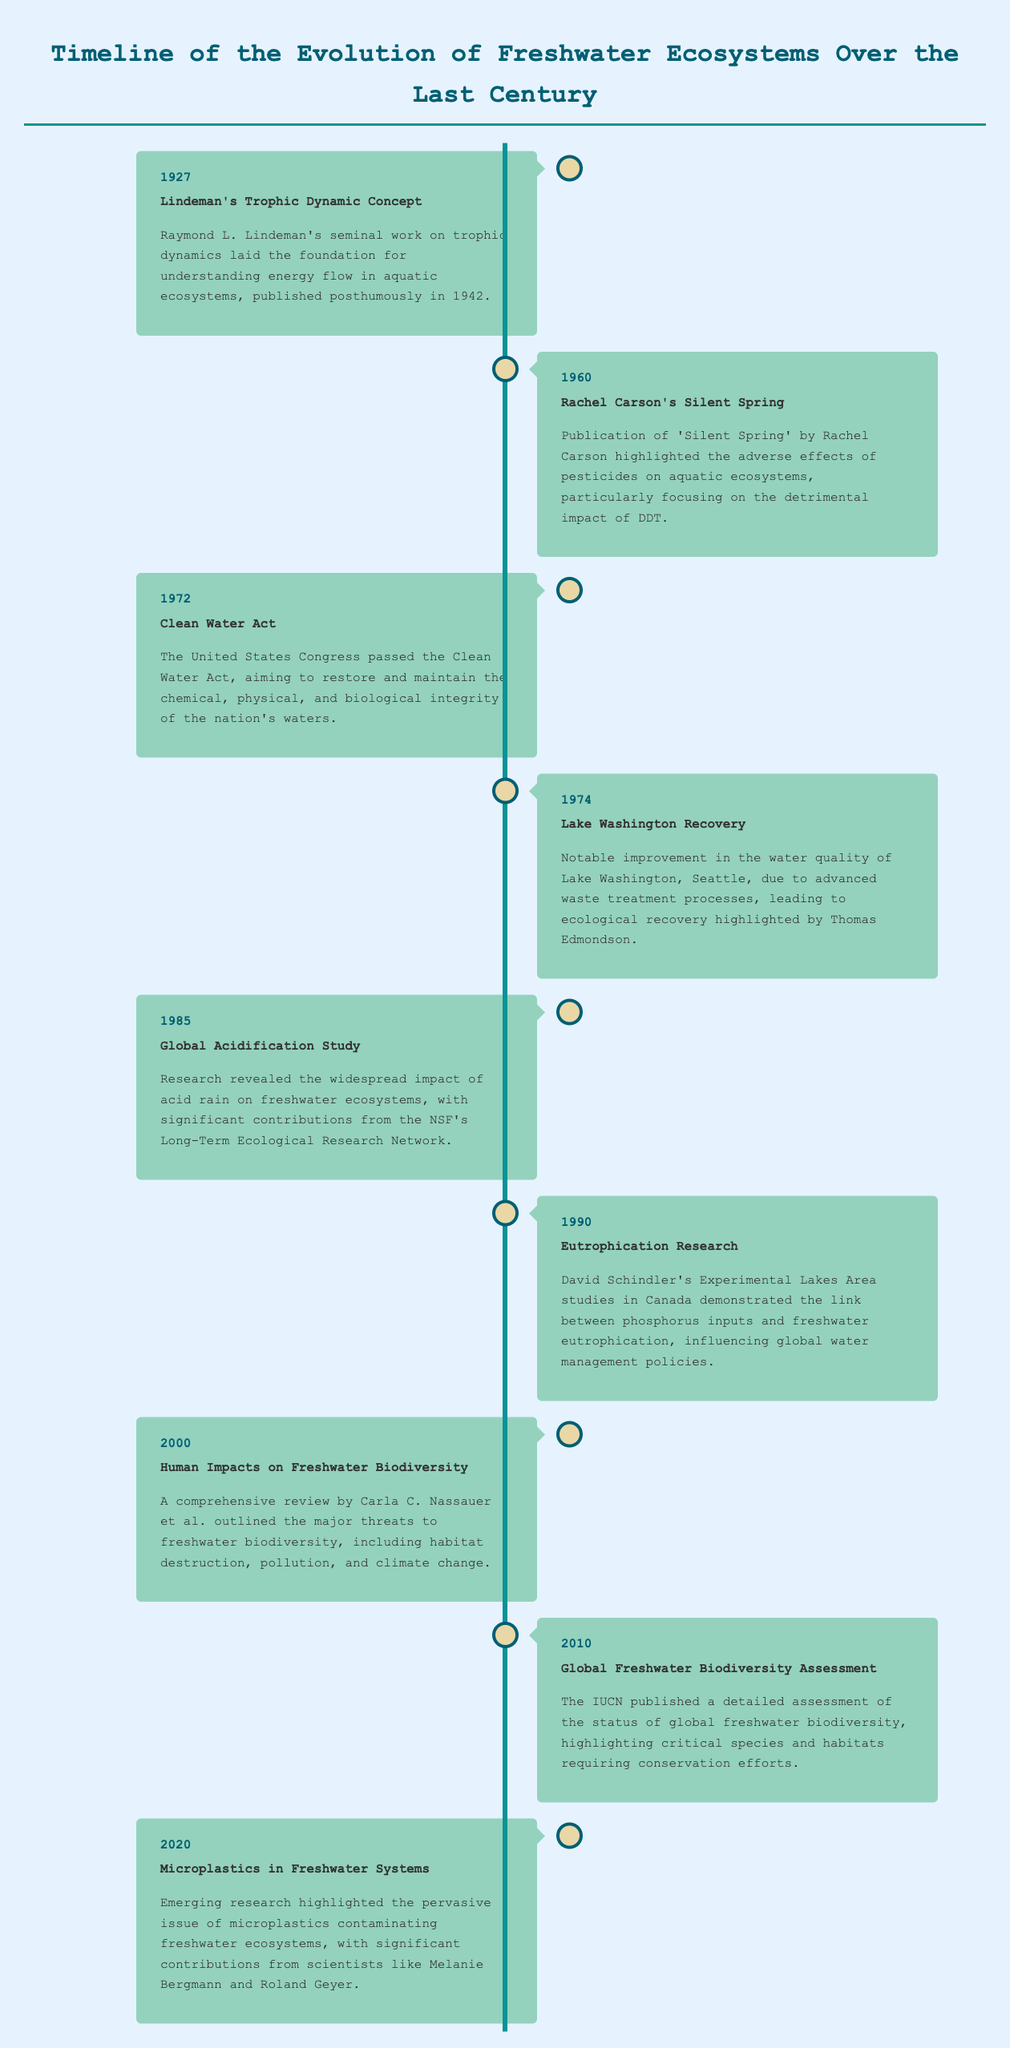what year was Lindeman's Trophic Dynamic Concept published? The timeline states that Lindeman's Trophic Dynamic Concept was referenced in 1927.
Answer: 1927 who wrote 'Silent Spring'? The event from 1960 mentions that 'Silent Spring' was published by Rachel Carson.
Answer: Rachel Carson what significant legislation was passed in 1972? The event from 1972 refers to the passing of the Clean Water Act by the United States Congress.
Answer: Clean Water Act what ecological recovery was noted in 1974? The 1974 entry highlights the notable improvement in the water quality of Lake Washington due to advanced waste treatment processes.
Answer: Lake Washington Recovery which event in 1990 linked phosphorus inputs to freshwater issues? The 1990 event describes David Schindler's research demonstrating the link between phosphorus inputs and freshwater eutrophication.
Answer: Eutrophication Research what emerging issue was highlighted in 2020? The timeline notes that microplastics contamination in freshwater systems was an emerging issue in 2020.
Answer: Microplastics how many key events are listed in the timeline? Counting the individual events described, there are a total of eight key events mentioned.
Answer: Eight which research area did the Global Freshwater Biodiversity Assessment focus on? The IUCN's assessment published in 2010 focused on the status of global freshwater biodiversity.
Answer: Freshwater biodiversity who contributed to the research on microplastics? The timeline from 2020 mentions scientists Melanie Bergmann and Roland Geyer contributing to research on microplastics.
Answer: Melanie Bergmann and Roland Geyer 